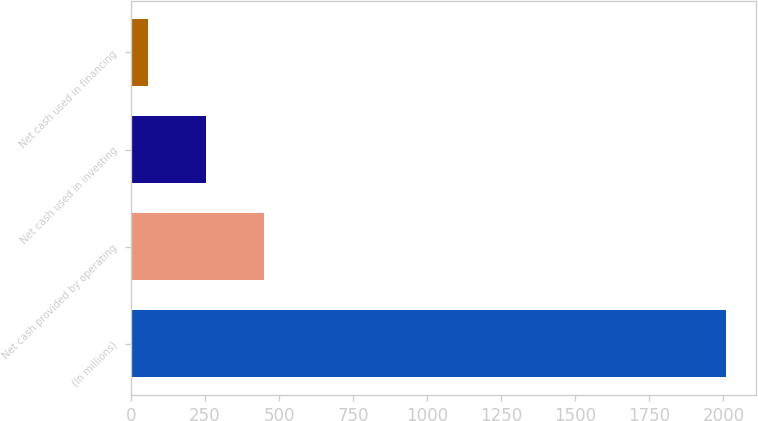Convert chart to OTSL. <chart><loc_0><loc_0><loc_500><loc_500><bar_chart><fcel>(In millions)<fcel>Net cash provided by operating<fcel>Net cash used in investing<fcel>Net cash used in financing<nl><fcel>2009<fcel>448.44<fcel>253.37<fcel>58.3<nl></chart> 